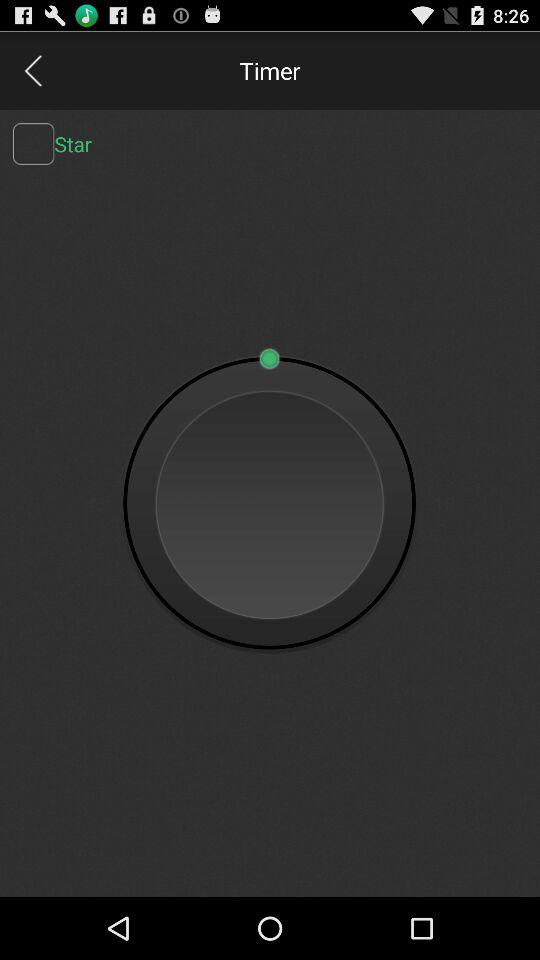How many ui elements are above the navbar?
Answer the question using a single word or phrase. 3 